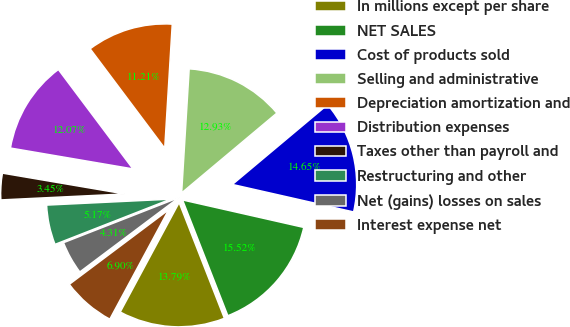<chart> <loc_0><loc_0><loc_500><loc_500><pie_chart><fcel>In millions except per share<fcel>NET SALES<fcel>Cost of products sold<fcel>Selling and administrative<fcel>Depreciation amortization and<fcel>Distribution expenses<fcel>Taxes other than payroll and<fcel>Restructuring and other<fcel>Net (gains) losses on sales<fcel>Interest expense net<nl><fcel>13.79%<fcel>15.52%<fcel>14.65%<fcel>12.93%<fcel>11.21%<fcel>12.07%<fcel>3.45%<fcel>5.17%<fcel>4.31%<fcel>6.9%<nl></chart> 